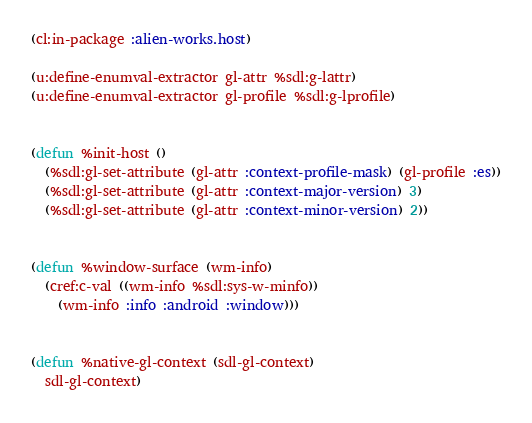Convert code to text. <code><loc_0><loc_0><loc_500><loc_500><_Lisp_>(cl:in-package :alien-works.host)

(u:define-enumval-extractor gl-attr %sdl:g-lattr)
(u:define-enumval-extractor gl-profile %sdl:g-lprofile)


(defun %init-host ()
  (%sdl:gl-set-attribute (gl-attr :context-profile-mask) (gl-profile :es))
  (%sdl:gl-set-attribute (gl-attr :context-major-version) 3)
  (%sdl:gl-set-attribute (gl-attr :context-minor-version) 2))


(defun %window-surface (wm-info)
  (cref:c-val ((wm-info %sdl:sys-w-minfo))
    (wm-info :info :android :window)))


(defun %native-gl-context (sdl-gl-context)
  sdl-gl-context)
</code> 